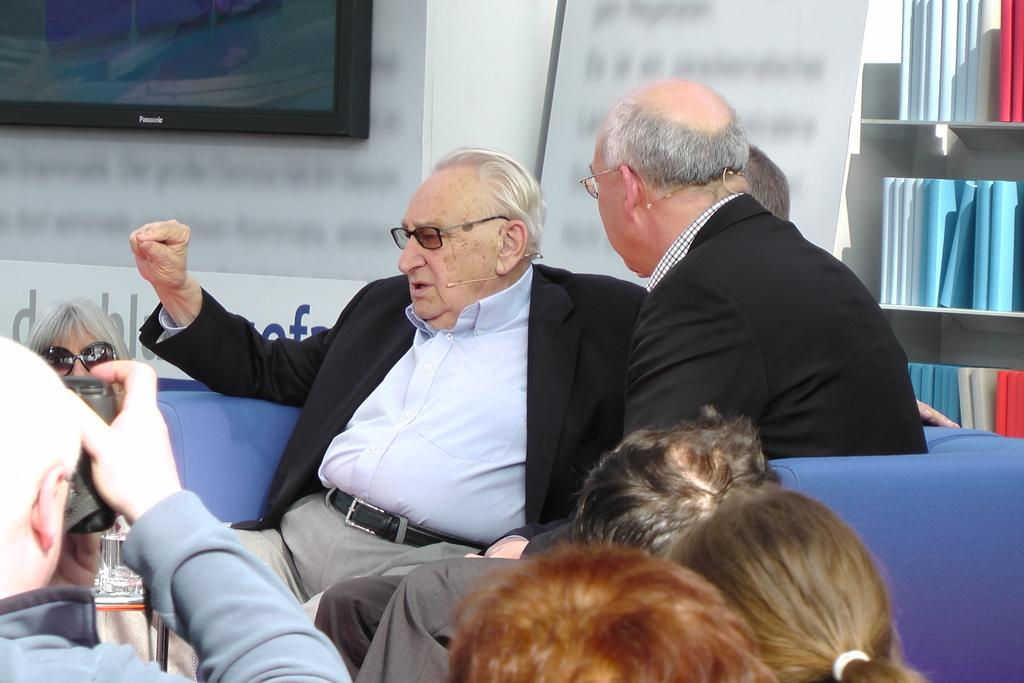How many people are present in the image? There are people in the image, but the exact number is not specified. What type of furniture is in the image? There is a sofa in the image. What is the purpose of the screen in the image? The purpose of the screen is not specified, but it is present in the image. What is the background of the image made of? There is a wall in the image, which suggests the background is made of a solid material. What is hanging on the wall in the image? There is a banner in the image, which is hanging on the wall. What can be found on the rack in the image? There is a rack filled with books in the image. What type of beast is causing a crime in the image? There is no beast or crime present in the image; it features people, a sofa, a screen, a wall, a banner, and a rack filled with books. How many yaks are visible in the image? There are no yaks present in the image. 